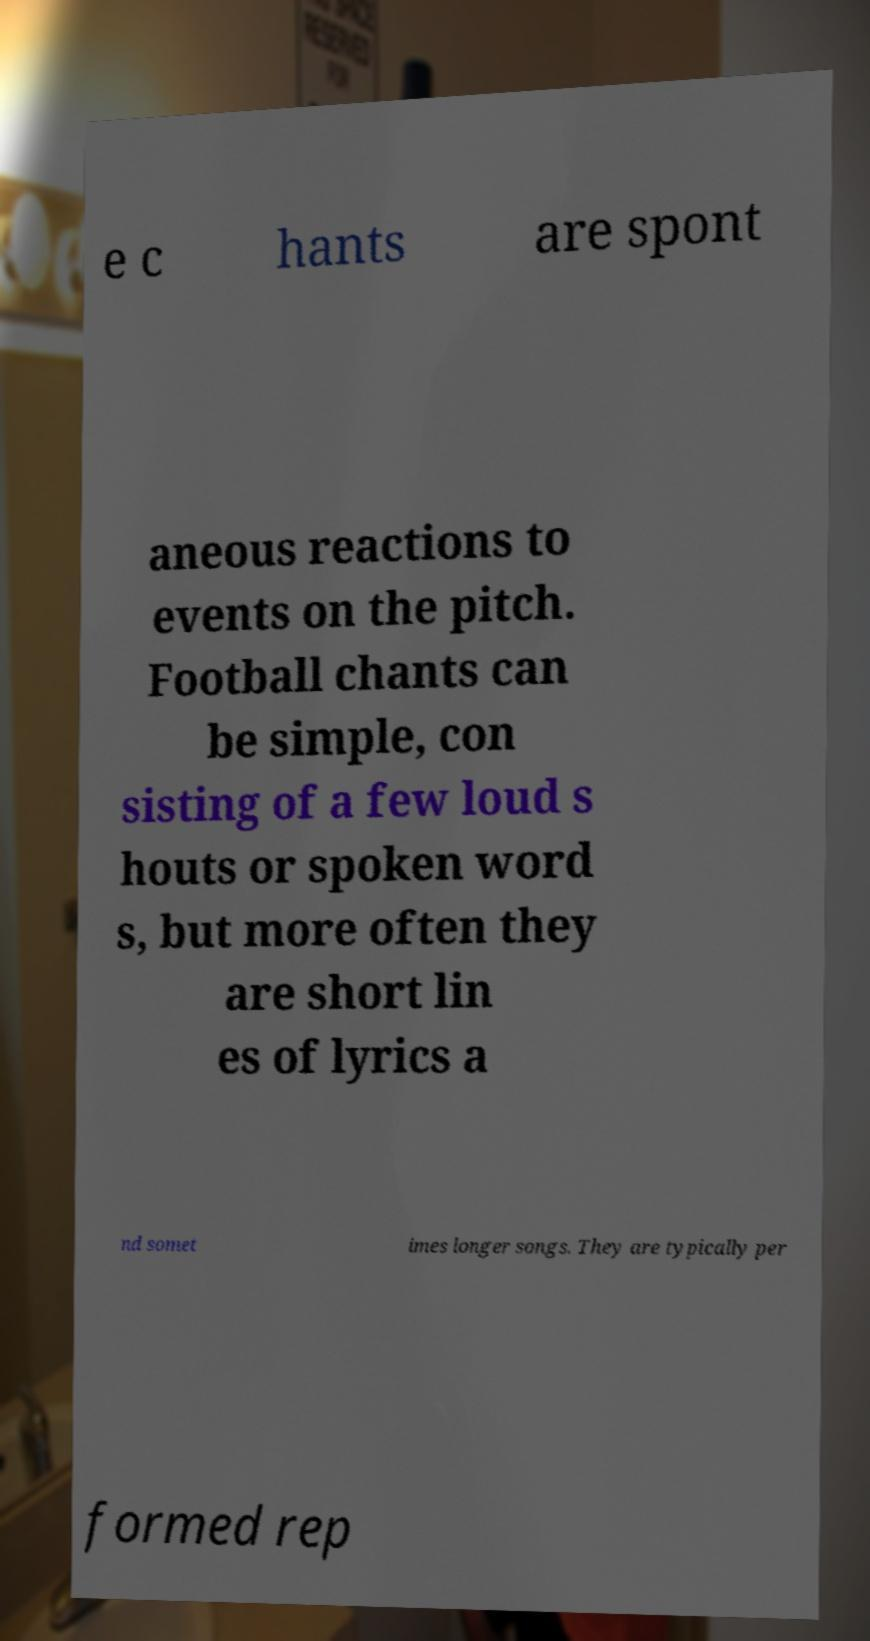Please read and relay the text visible in this image. What does it say? e c hants are spont aneous reactions to events on the pitch. Football chants can be simple, con sisting of a few loud s houts or spoken word s, but more often they are short lin es of lyrics a nd somet imes longer songs. They are typically per formed rep 